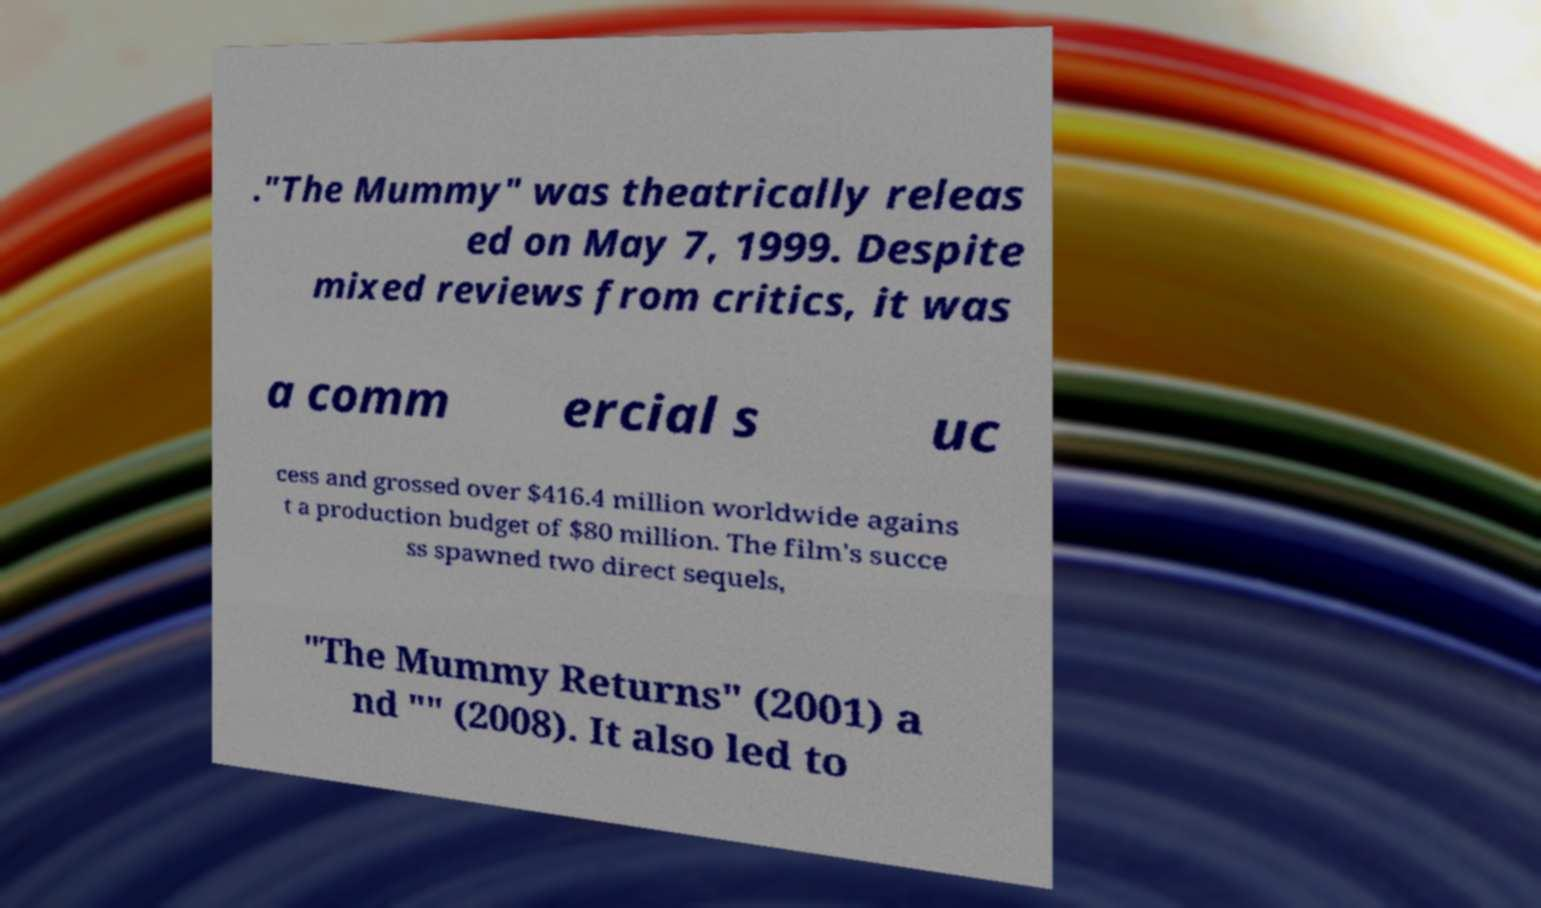I need the written content from this picture converted into text. Can you do that? ."The Mummy" was theatrically releas ed on May 7, 1999. Despite mixed reviews from critics, it was a comm ercial s uc cess and grossed over $416.4 million worldwide agains t a production budget of $80 million. The film's succe ss spawned two direct sequels, "The Mummy Returns" (2001) a nd "" (2008). It also led to 